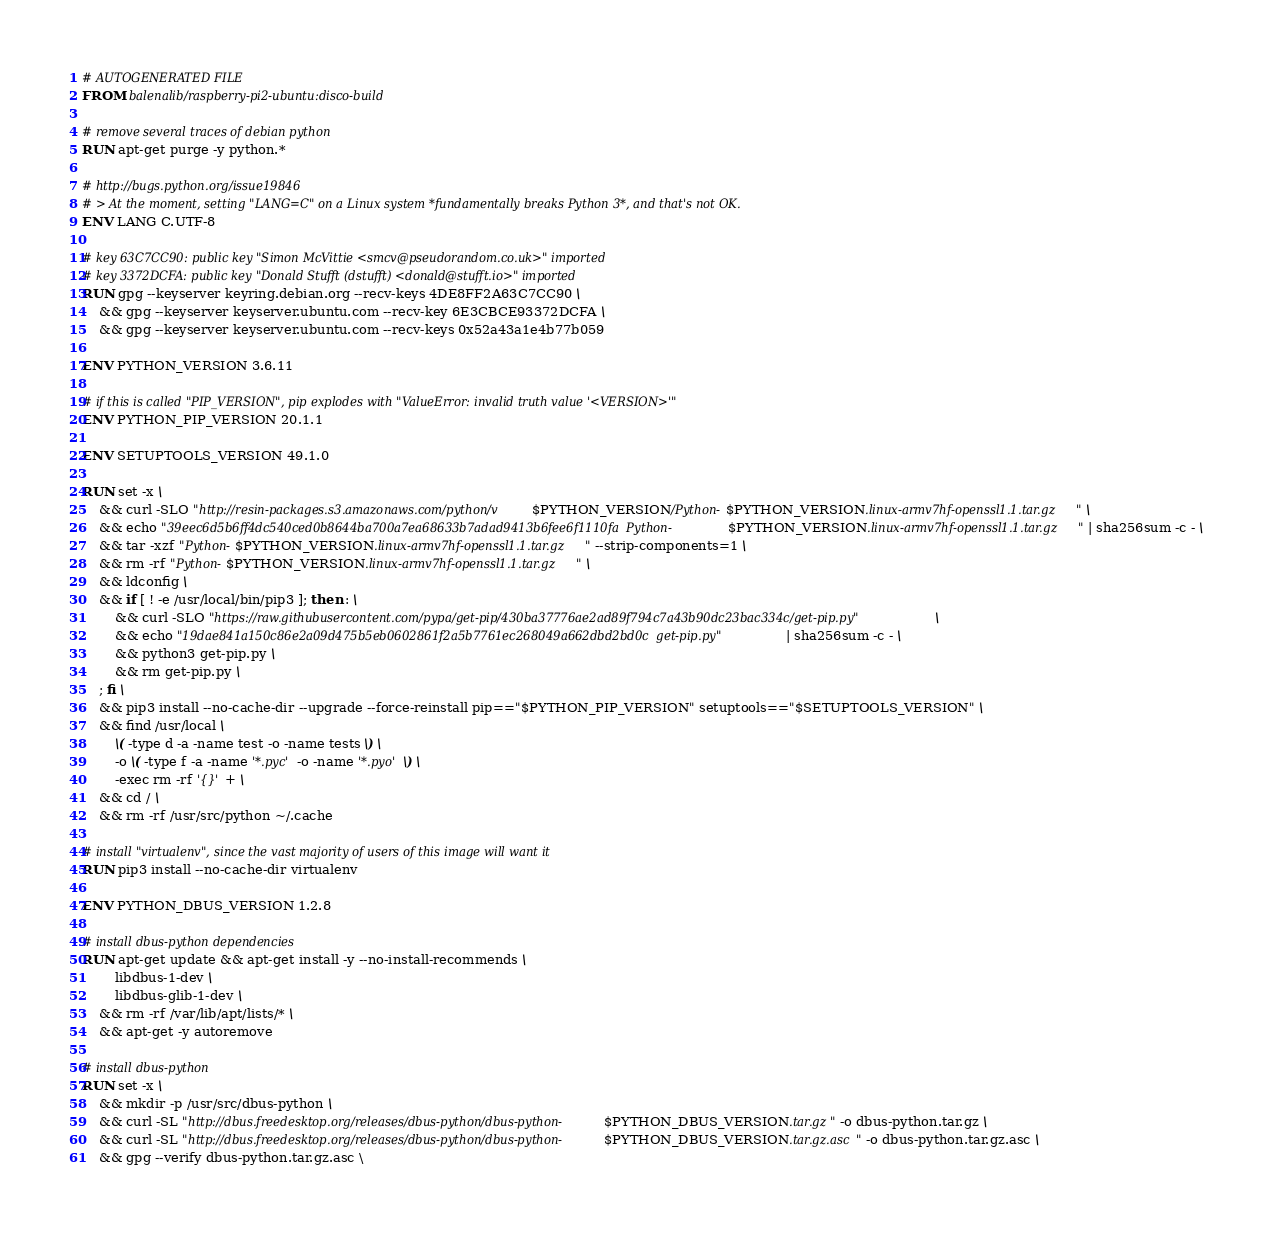Convert code to text. <code><loc_0><loc_0><loc_500><loc_500><_Dockerfile_># AUTOGENERATED FILE
FROM balenalib/raspberry-pi2-ubuntu:disco-build

# remove several traces of debian python
RUN apt-get purge -y python.*

# http://bugs.python.org/issue19846
# > At the moment, setting "LANG=C" on a Linux system *fundamentally breaks Python 3*, and that's not OK.
ENV LANG C.UTF-8

# key 63C7CC90: public key "Simon McVittie <smcv@pseudorandom.co.uk>" imported
# key 3372DCFA: public key "Donald Stufft (dstufft) <donald@stufft.io>" imported
RUN gpg --keyserver keyring.debian.org --recv-keys 4DE8FF2A63C7CC90 \
	&& gpg --keyserver keyserver.ubuntu.com --recv-key 6E3CBCE93372DCFA \
	&& gpg --keyserver keyserver.ubuntu.com --recv-keys 0x52a43a1e4b77b059

ENV PYTHON_VERSION 3.6.11

# if this is called "PIP_VERSION", pip explodes with "ValueError: invalid truth value '<VERSION>'"
ENV PYTHON_PIP_VERSION 20.1.1

ENV SETUPTOOLS_VERSION 49.1.0

RUN set -x \
	&& curl -SLO "http://resin-packages.s3.amazonaws.com/python/v$PYTHON_VERSION/Python-$PYTHON_VERSION.linux-armv7hf-openssl1.1.tar.gz" \
	&& echo "39eec6d5b6ff4dc540ced0b8644ba700a7ea68633b7adad9413b6fee6f1110fa  Python-$PYTHON_VERSION.linux-armv7hf-openssl1.1.tar.gz" | sha256sum -c - \
	&& tar -xzf "Python-$PYTHON_VERSION.linux-armv7hf-openssl1.1.tar.gz" --strip-components=1 \
	&& rm -rf "Python-$PYTHON_VERSION.linux-armv7hf-openssl1.1.tar.gz" \
	&& ldconfig \
	&& if [ ! -e /usr/local/bin/pip3 ]; then : \
		&& curl -SLO "https://raw.githubusercontent.com/pypa/get-pip/430ba37776ae2ad89f794c7a43b90dc23bac334c/get-pip.py" \
		&& echo "19dae841a150c86e2a09d475b5eb0602861f2a5b7761ec268049a662dbd2bd0c  get-pip.py" | sha256sum -c - \
		&& python3 get-pip.py \
		&& rm get-pip.py \
	; fi \
	&& pip3 install --no-cache-dir --upgrade --force-reinstall pip=="$PYTHON_PIP_VERSION" setuptools=="$SETUPTOOLS_VERSION" \
	&& find /usr/local \
		\( -type d -a -name test -o -name tests \) \
		-o \( -type f -a -name '*.pyc' -o -name '*.pyo' \) \
		-exec rm -rf '{}' + \
	&& cd / \
	&& rm -rf /usr/src/python ~/.cache

# install "virtualenv", since the vast majority of users of this image will want it
RUN pip3 install --no-cache-dir virtualenv

ENV PYTHON_DBUS_VERSION 1.2.8

# install dbus-python dependencies 
RUN apt-get update && apt-get install -y --no-install-recommends \
		libdbus-1-dev \
		libdbus-glib-1-dev \
	&& rm -rf /var/lib/apt/lists/* \
	&& apt-get -y autoremove

# install dbus-python
RUN set -x \
	&& mkdir -p /usr/src/dbus-python \
	&& curl -SL "http://dbus.freedesktop.org/releases/dbus-python/dbus-python-$PYTHON_DBUS_VERSION.tar.gz" -o dbus-python.tar.gz \
	&& curl -SL "http://dbus.freedesktop.org/releases/dbus-python/dbus-python-$PYTHON_DBUS_VERSION.tar.gz.asc" -o dbus-python.tar.gz.asc \
	&& gpg --verify dbus-python.tar.gz.asc \</code> 